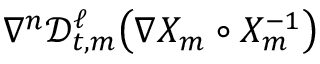Convert formula to latex. <formula><loc_0><loc_0><loc_500><loc_500>\nabla ^ { n } \ m a t h s c r { D } _ { t , m } ^ { \ell } \left ( \nabla X _ { m } \circ X _ { m } ^ { - 1 } \right )</formula> 